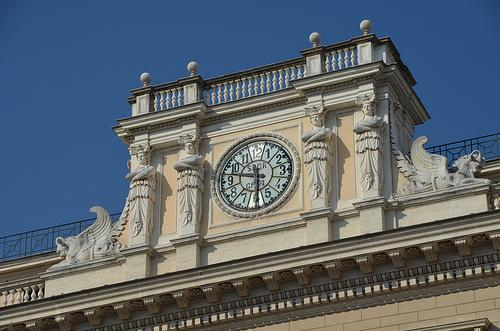What are the decorative elements on the ledge of the roof? The ledge of the roof has cement balls as decorative elements, placed on both left and right sides. What architectural style is the building in the image, and what is it made of? The building is classical architecture, made of tan-colored stone bricks with a metal railing at the back. Summarize the appearance of the clock tower in the image. The clock tower has a black and white clock with white face, black hands, and black numbers, surrounded by statues against a clear blue sky. Mention the colors of the sky and the clock in the image. The sky is a light blue color, and the clock has a black and white clock face with black hands and black numbers. State the time shown in the clock tower and give one interesting detail about it. The clock tower shows the time at 5:47, and it has an ornate design reading 9:30 AM. Describe the overall scene of the image, including the building and the sky. The image shows a classical stone building with a clock tower and statues, set against a clear light blue sky with white clouds. Describe the statues surrounding the clock tower in the image. There are statues of winged creatures and human figures with crossed arms on both sides of the clock tower, some facing away from the clock. How are the human-like statues in the image positioned? The human-like statues are positioned next to the clock, on both left and right sides, with their arms crossed. Talk about the location and appearance of the statues next to the clock. The statues next to the clock are standing on both left and right sides, with arms crossed and wings visible in some of them. Describe the weather conditions visible in the image. The weather appears to be very clear, with white clouds scattered across a light blue sky. 